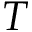Convert formula to latex. <formula><loc_0><loc_0><loc_500><loc_500>T</formula> 